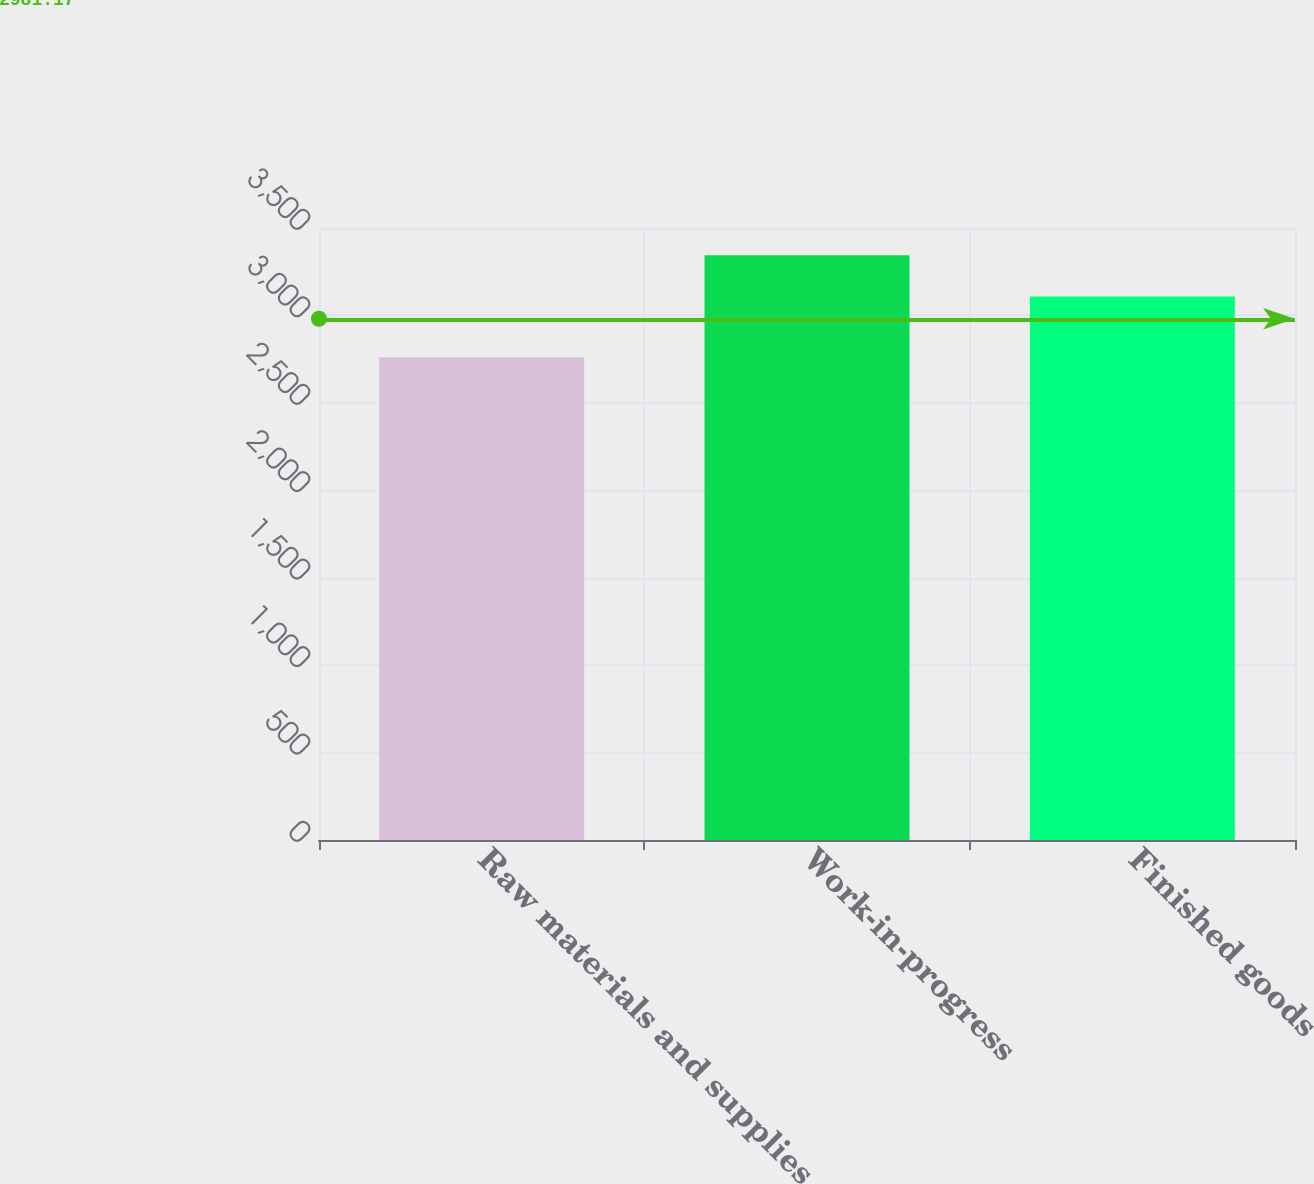Convert chart to OTSL. <chart><loc_0><loc_0><loc_500><loc_500><bar_chart><fcel>Raw materials and supplies<fcel>Work-in-progress<fcel>Finished goods<nl><fcel>2759<fcel>3344<fcel>3108<nl></chart> 